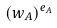<formula> <loc_0><loc_0><loc_500><loc_500>( w _ { A } ) ^ { e _ { A } }</formula> 